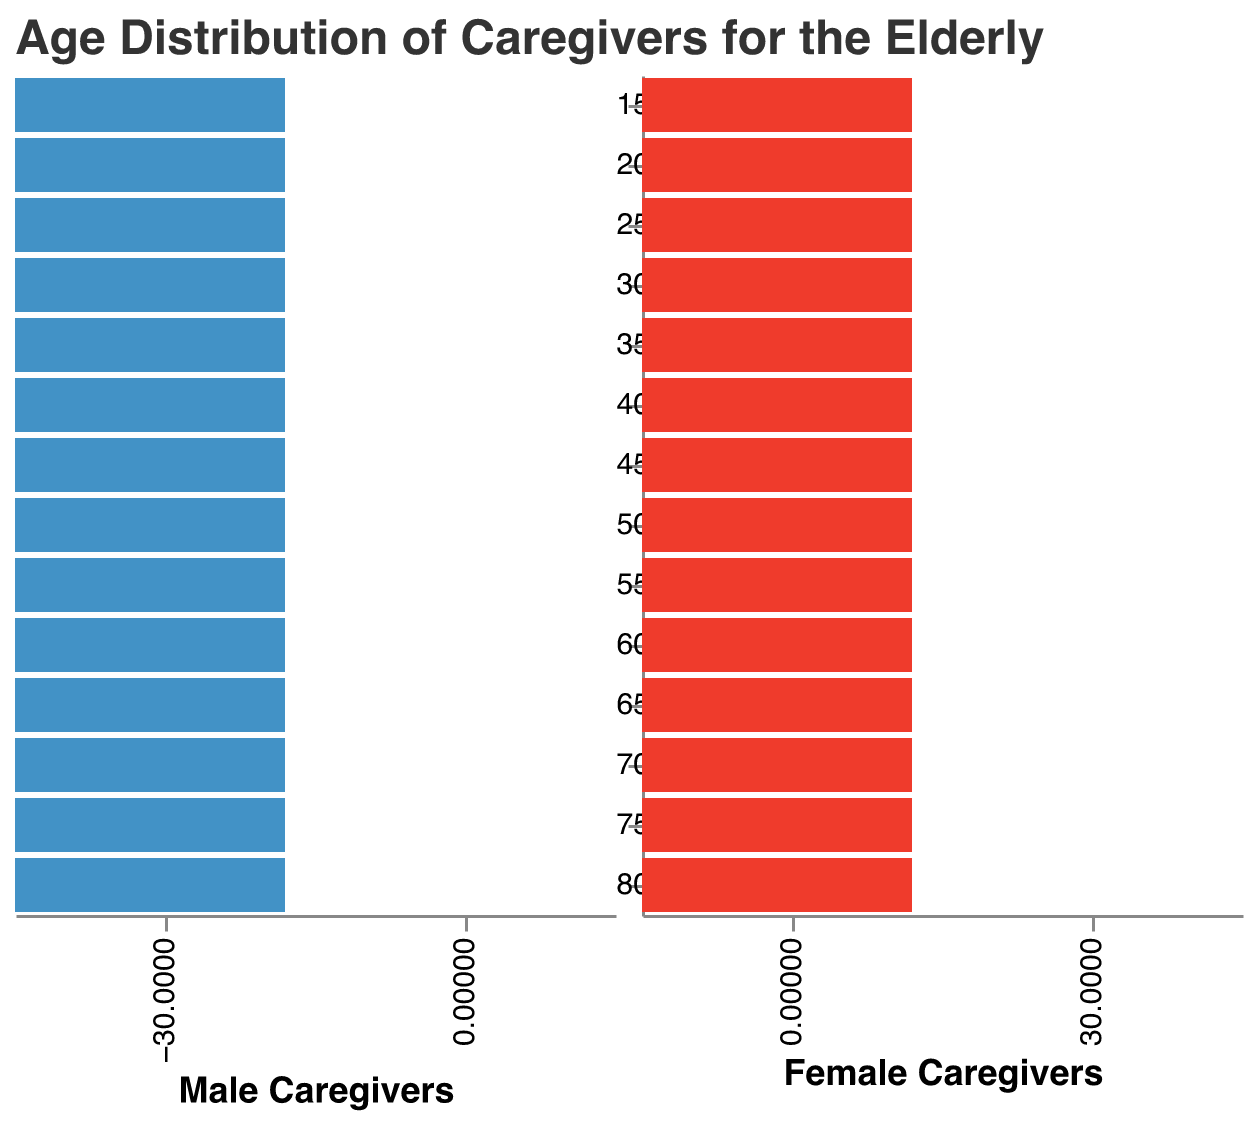What's the title of the figure? The title of the figure is found at the top, displaying the main subject of the visualization.
Answer: Age Distribution of Caregivers for the Elderly How many age groups are depicted in the figure? Count the number of distinct age groups listed along the y-axis.
Answer: 14 What color represents male caregivers in the figure? Identify the color used in the left half of the population pyramid representing male caregivers.
Answer: Blue Which age group has the highest number of female caregivers? The bar that extends furthest to the right on the female side indicates the highest count of female caregivers.
Answer: 55-59 How many male caregivers are in the 50-54 age group? Locate the bar for the 50-54 age group on the male side and read the number associated with the bar's length.
Answer: 18 Compare the number of male and female caregivers in the 45-49 age group. Which is higher? Observe the length of the bars for both male and female in the 45-49 age group and compare their values.
Answer: Female caregivers What's the total number of caregivers (both male and female) in the 80+ age group? Sum the count of male and female caregivers in the 80+ age group. 2 (male) + 3 (female) = 5
Answer: 5 In which age group is the difference between male and female caregivers the greatest? Calculate the difference for each age group: the age group with the largest numerical difference is the answer.
Answer: 55-59 Which age group has the least number of male caregivers? Identify the age group with the shortest bar on the male side.
Answer: 15-19 Calculate the average number of female caregivers in the 25-39 age groups. Sum the number of female caregivers in the age groups 25-29, 30-34, and 35-39, then divide by 3. (8 + 12 + 15) / 3 = 35 / 3
Answer: 11.67 